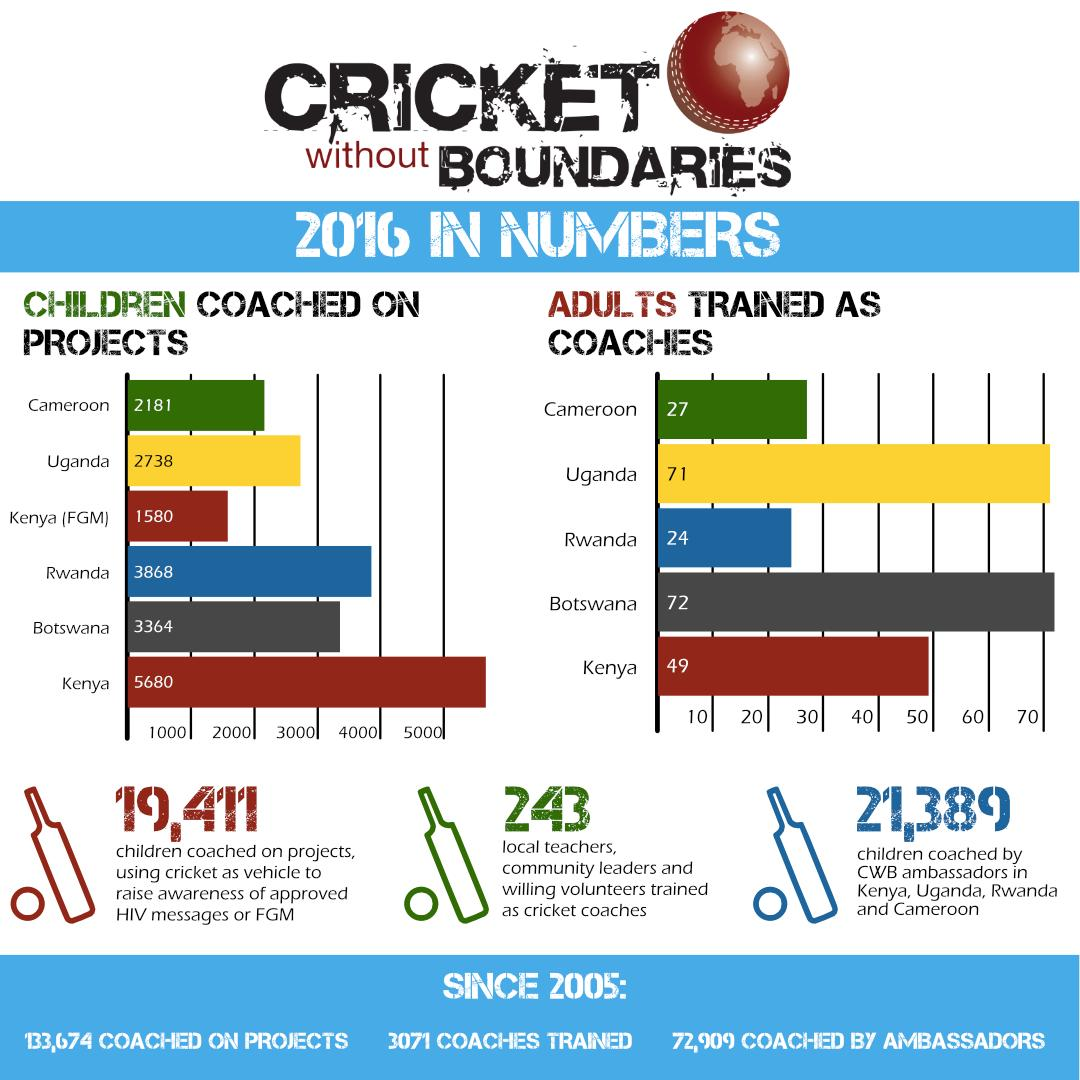Highlight a few significant elements in this photo. In Cameroon and Uganda, a total of 4,919 children have been coached on projects. In Rwanda and Kenya, a total of 73 adults have been trained as coaches. According to the data, a total of 95 adults were trained as coaches in Uganda and Rwanda, taken together. A total of 243 local teachers, community leaders, and willing volunteers were trained as cricket coaches. The total number of children coached on projects in Rwanda and Kenya is 9548. 